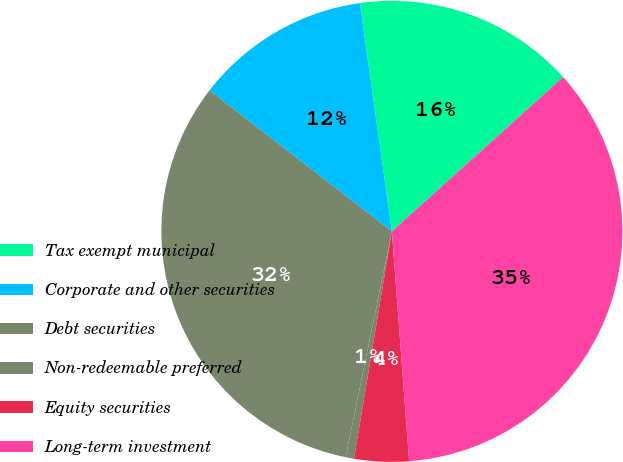<chart> <loc_0><loc_0><loc_500><loc_500><pie_chart><fcel>Tax exempt municipal<fcel>Corporate and other securities<fcel>Debt securities<fcel>Non-redeemable preferred<fcel>Equity securities<fcel>Long-term investment<nl><fcel>15.54%<fcel>12.31%<fcel>32.26%<fcel>0.59%<fcel>3.82%<fcel>35.48%<nl></chart> 